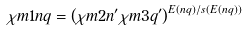Convert formula to latex. <formula><loc_0><loc_0><loc_500><loc_500>\chi m 1 { n q } = \left ( \chi m 2 { n ^ { \prime } } \chi m 3 { q ^ { \prime } } \right ) ^ { E ( n q ) / s ( E ( n q ) ) }</formula> 